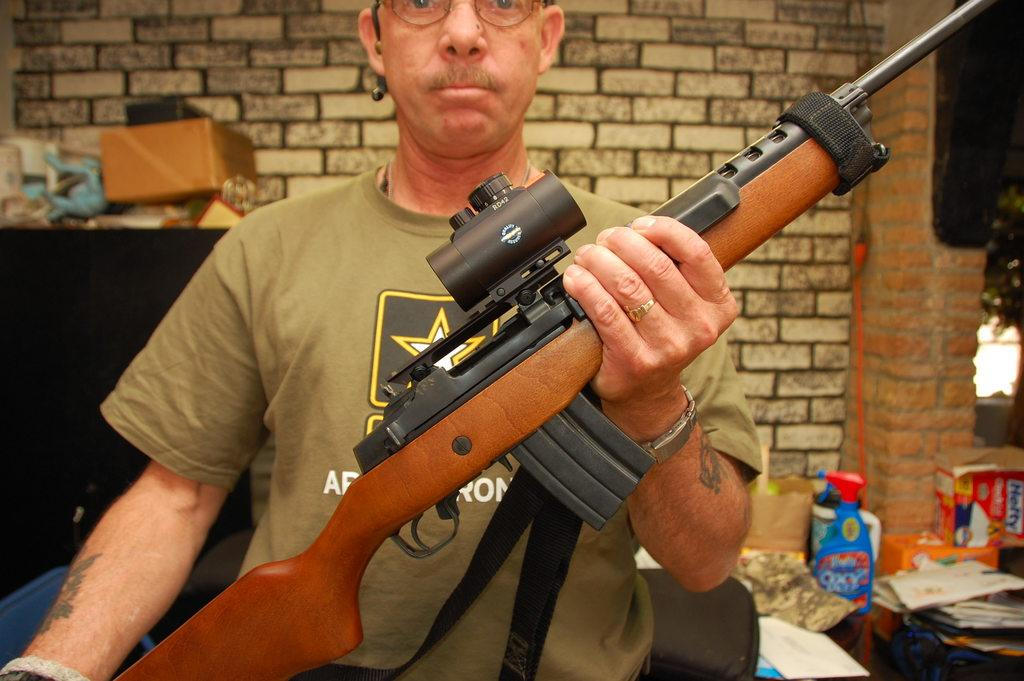Who is present in the image? There is a man in the image. What is the man holding in the image? The man is holding a gun. What can be seen in the background of the image? There is a wall, papers, and some objects in the background of the image. How many cows are visible in the image? There are no cows present in the image. What type of afterthought is the man having in the image? There is no indication of any afterthought in the image; the man is simply holding a gun. 